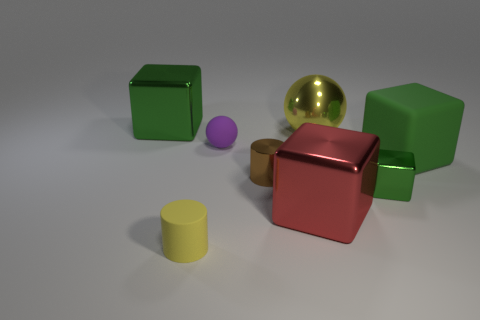Subtract all gray cylinders. How many green cubes are left? 3 Subtract 1 cubes. How many cubes are left? 3 Add 1 spheres. How many objects exist? 9 Subtract all spheres. How many objects are left? 6 Add 1 large green metal blocks. How many large green metal blocks exist? 2 Subtract 0 brown blocks. How many objects are left? 8 Subtract all tiny brown metal cylinders. Subtract all tiny yellow rubber cylinders. How many objects are left? 6 Add 1 small brown metallic things. How many small brown metallic things are left? 2 